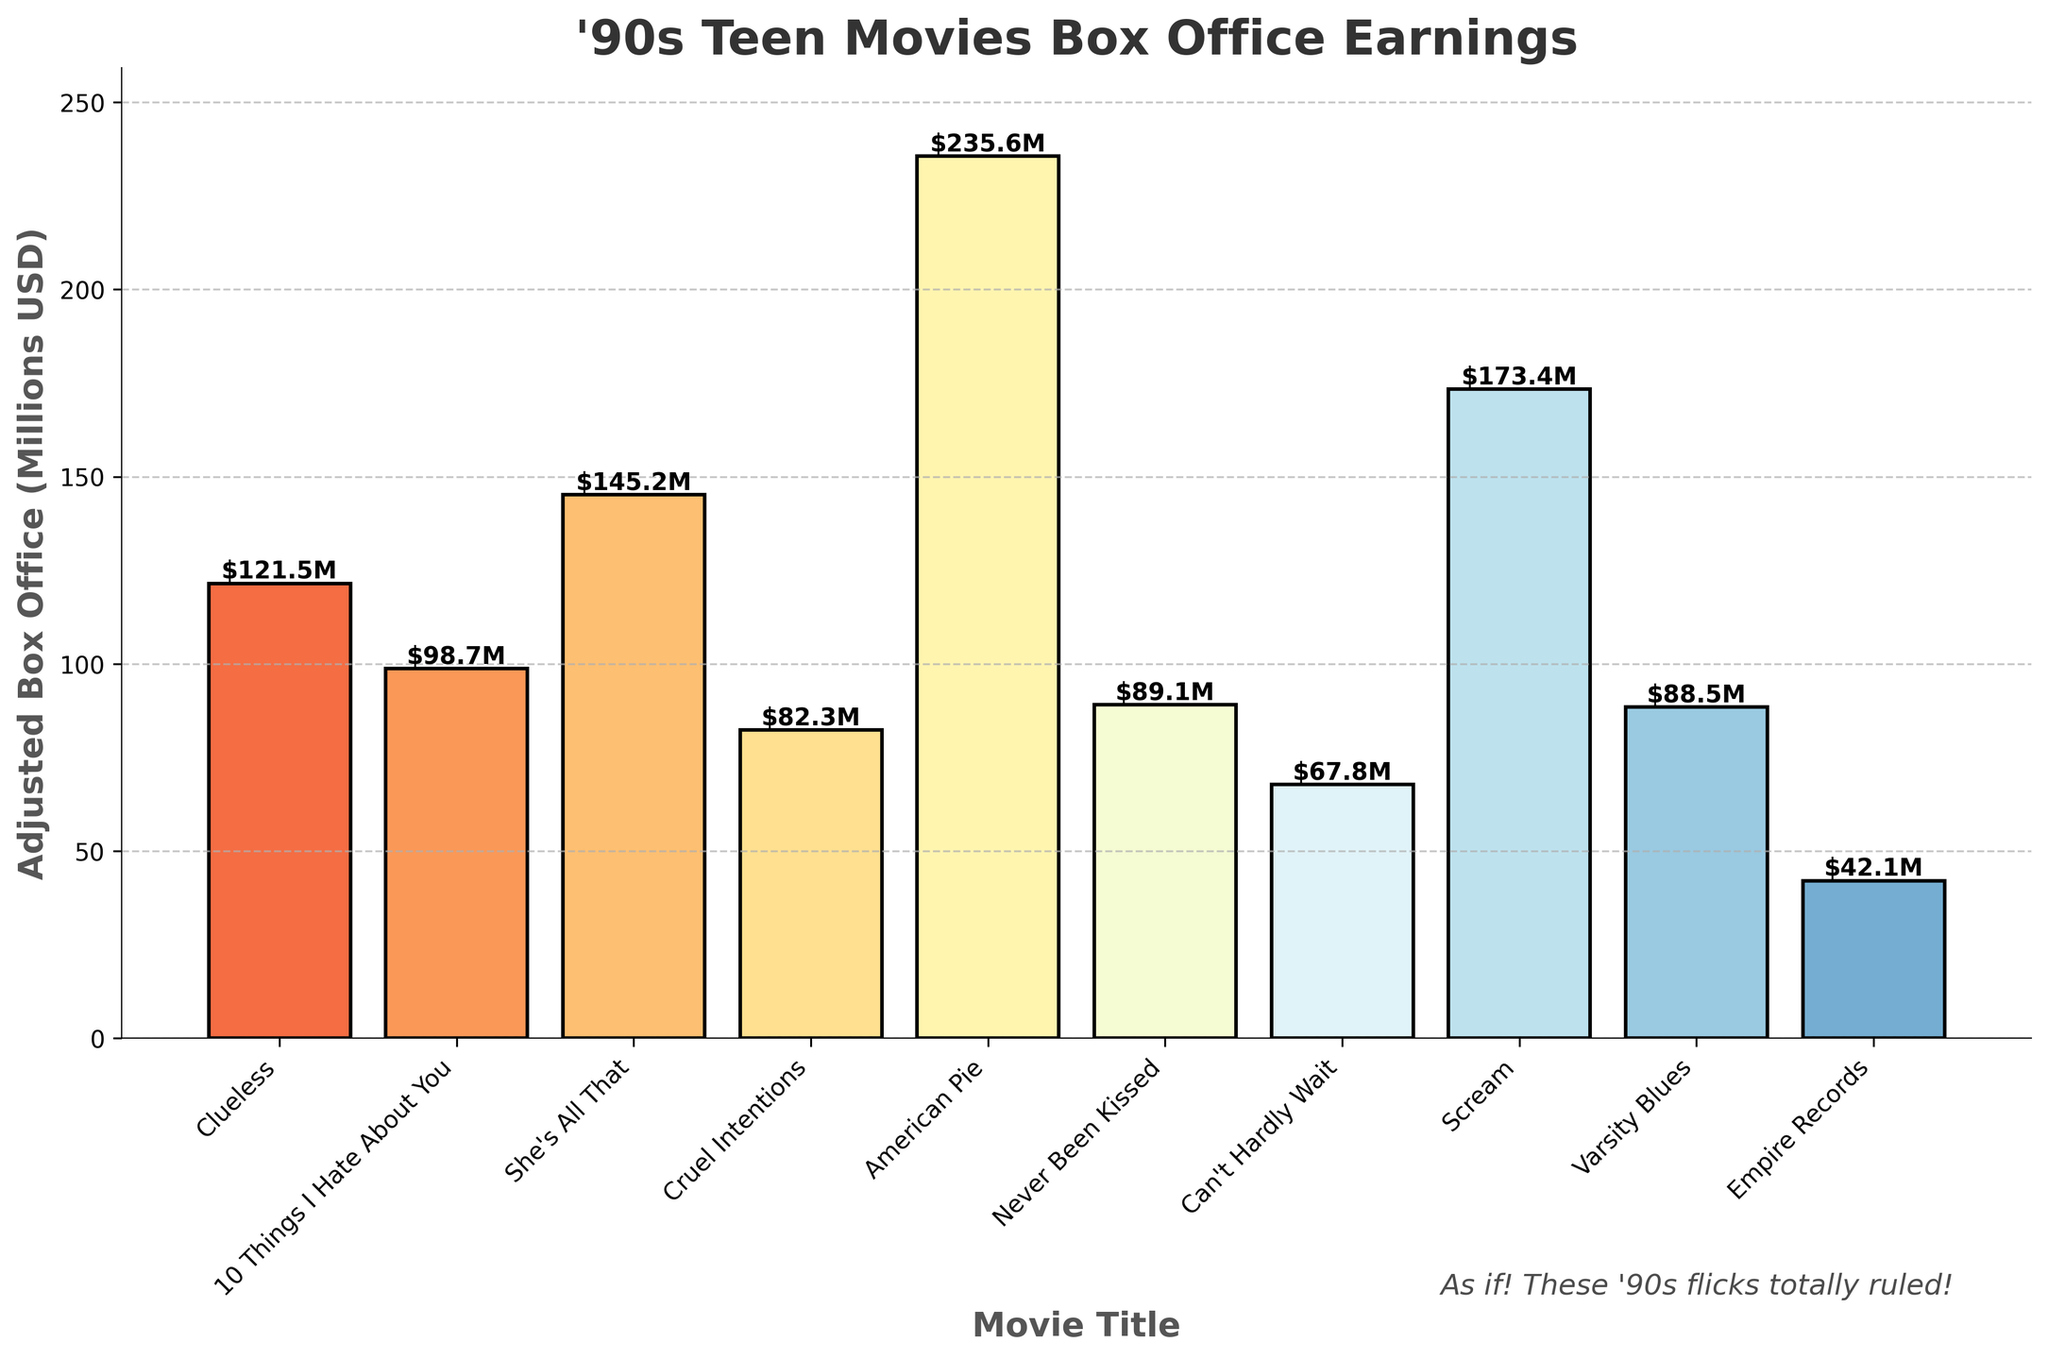What movie has the highest adjusted box office earnings? Look at the bar chart and find the tallest bar. The movie with the highest bar is "American Pie" with an adjusted box office earning of $235.6 million.
Answer: American Pie Which movie earned more, "10 Things I Hate About You" or "Never Been Kissed"? Find the bars representing "10 Things I Hate About You" with $98.7 million and "Never Been Kissed" with $89.1 million. Compare their heights. "10 Things I Hate About You" is higher, showing it earned more.
Answer: 10 Things I Hate About You What is the total adjusted box office earning for "Clueless" and "Scream"? Add the adjusted box office earnings of "Clueless" ($121.5 million) and "Scream" ($173.4 million). 121.5 + 173.4 = 294.9
Answer: 294.9 Which movies earned less than $100 million? Identify the bars that are below the $100 million mark on the vertical axis. The movies are "10 Things I Hate About You" ($98.7M), "Cruel Intentions" ($82.3M), "Never Been Kissed" ($89.1M), "Can't Hardly Wait" ($67.8M), "Varsity Blues" ($88.5M), and "Empire Records" ($42.1M).
Answer: 10 Things I Hate About You, Cruel Intentions, Never Been Kissed, Can't Hardly Wait, Varsity Blues, Empire Records What is the average adjusted box office earning of all movies on the chart? Add up all the adjusted box office earnings and divide by the number of movies. (121.5+98.7+145.2+82.3+235.6+89.1+67.8+173.4+88.5+42.1) / 10 = 114.42 million
Answer: 114.42 Which movie has the least adjusted box office earnings? Find the shortest bar on the chart. The movie with the shortest bar is "Empire Records" with an adjusted box office earning of $42.1 million.
Answer: Empire Records What is the difference in earnings between "She's All That" and "Can't Hardly Wait"? Subtract the adjusted box office earning of "Can't Hardly Wait" ($67.8 million) from "She's All That" ($145.2 million). 145.2 - 67.8 = 77.4 million
Answer: 77.4 How many movies earned more than $120 million? Identify the bars that are above the $120 million mark on the vertical axis. The movies are "Clueless" ($121.5M), "She's All That" ($145.2M), "American Pie" ($235.6M), and "Scream" ($173.4M). There are 4 movies in total.
Answer: 4 Which movie has an earnings figure written on its bar that starts with a 9? Look at the labels on top of the bars. The movie with a label starting with 9 is "10 Things I Hate About You" ($98.7 million).
Answer: 10 Things I Hate About You 